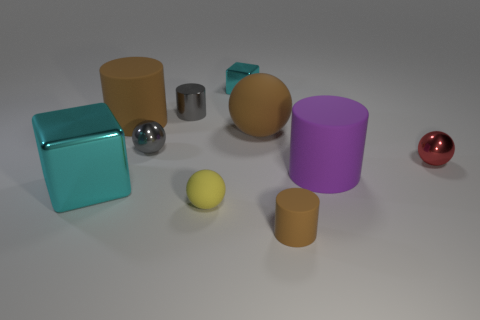The red shiny object is what shape?
Your answer should be very brief. Sphere. There is a metallic block behind the big matte cylinder that is to the left of the small yellow matte ball; are there any gray objects to the right of it?
Provide a short and direct response. No. The tiny ball in front of the metallic cube that is in front of the brown matte thing that is to the left of the big ball is what color?
Provide a succinct answer. Yellow. There is a gray thing that is the same shape as the small yellow rubber object; what is its material?
Give a very brief answer. Metal. How big is the cyan shiny object that is behind the small red sphere on the right side of the purple object?
Keep it short and to the point. Small. What material is the cyan cube behind the big purple rubber cylinder?
Your response must be concise. Metal. What is the size of the gray cylinder that is the same material as the small cyan thing?
Your answer should be compact. Small. How many tiny brown objects have the same shape as the tiny yellow rubber object?
Keep it short and to the point. 0. Is the shape of the purple matte object the same as the cyan metallic thing in front of the large purple cylinder?
Ensure brevity in your answer.  No. There is a shiny object that is the same color as the small metal cylinder; what shape is it?
Your response must be concise. Sphere. 